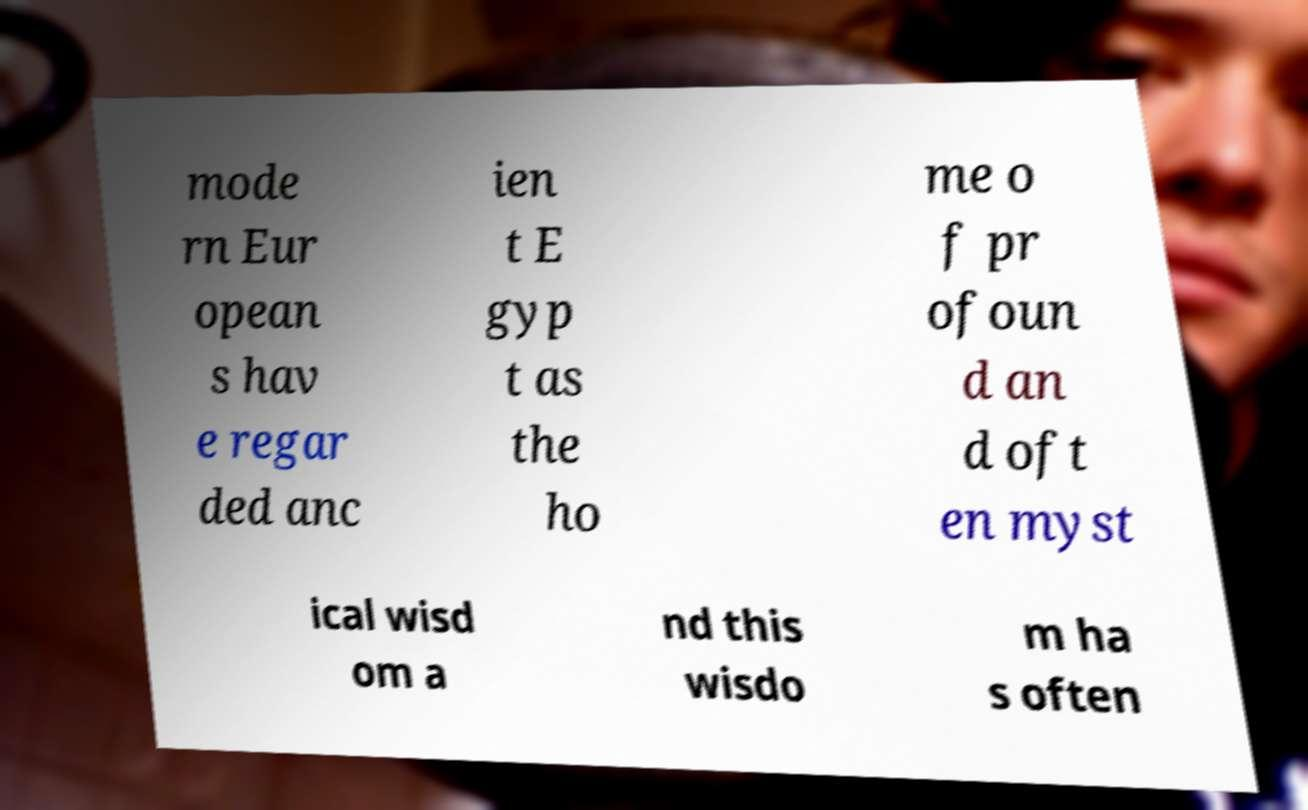Can you read and provide the text displayed in the image?This photo seems to have some interesting text. Can you extract and type it out for me? mode rn Eur opean s hav e regar ded anc ien t E gyp t as the ho me o f pr ofoun d an d oft en myst ical wisd om a nd this wisdo m ha s often 